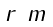Convert formula to latex. <formula><loc_0><loc_0><loc_500><loc_500>\begin{smallmatrix} r & m \end{smallmatrix}</formula> 